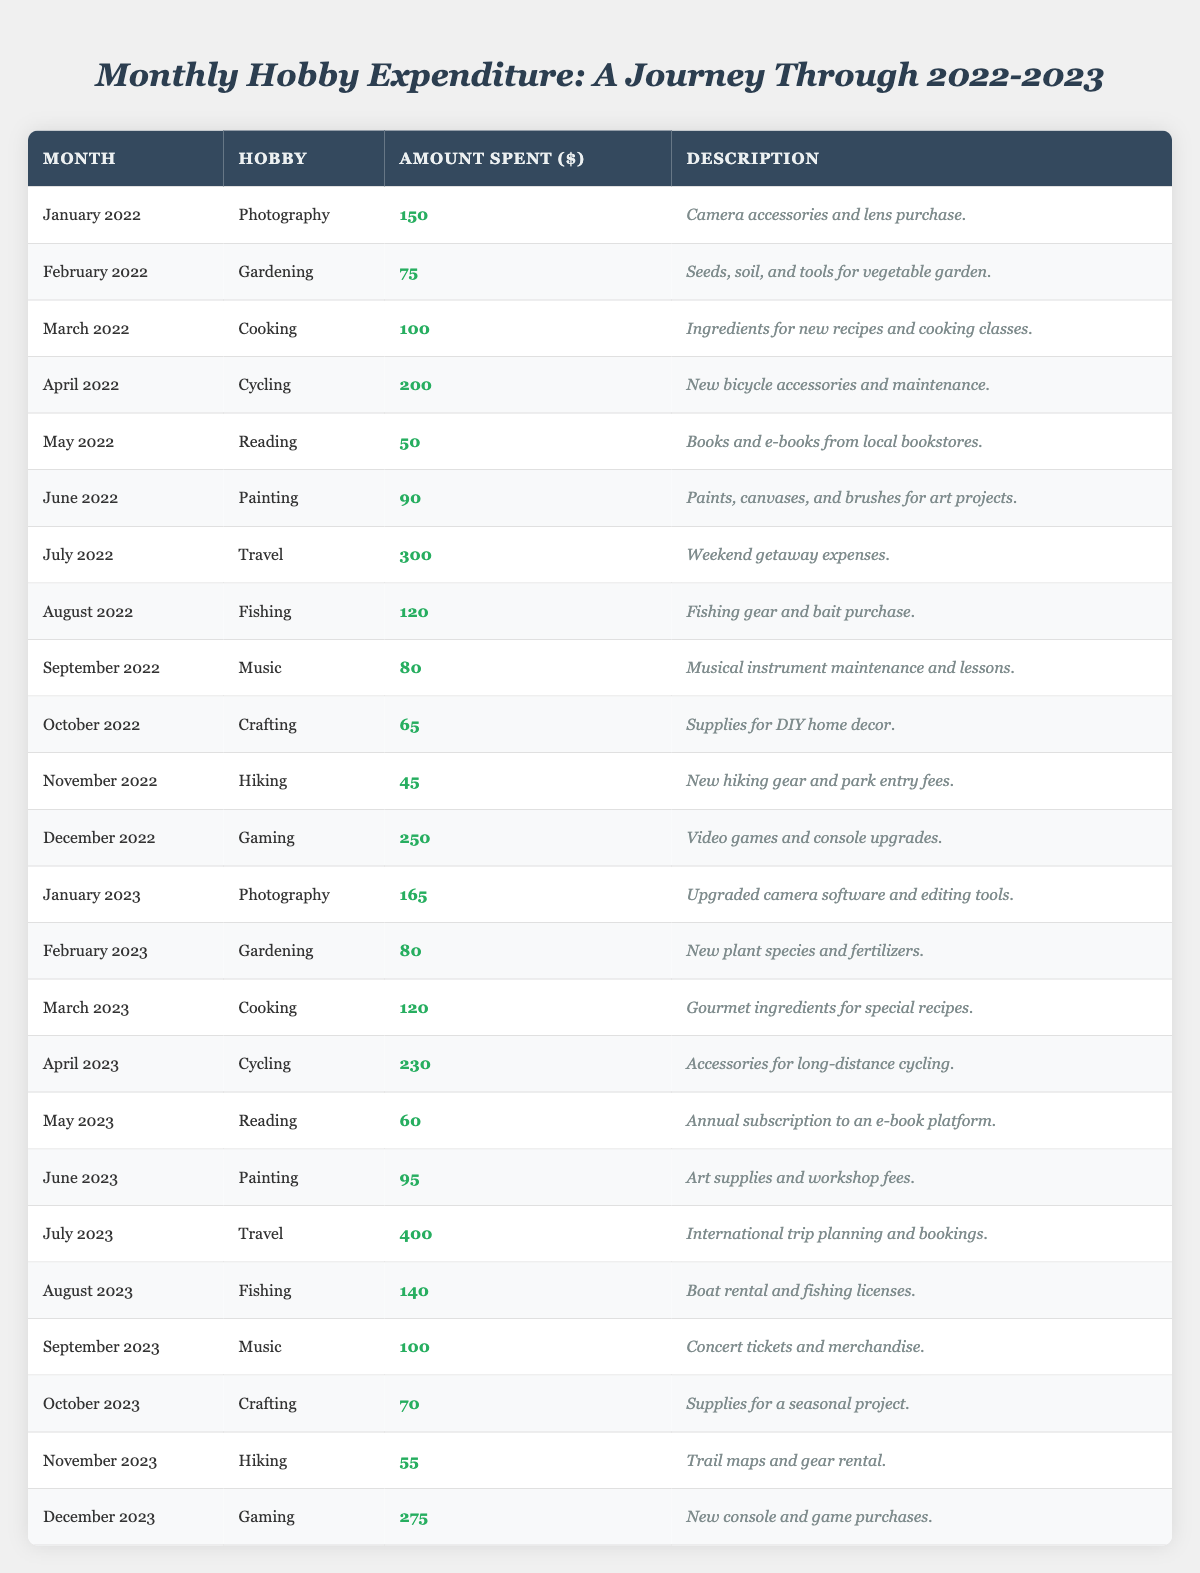What was the total expenditure on Cooking from 2022 to 2023? In 2022, the expenditure on Cooking was $100 in March and $120 in March 2023. Adding these amounts together gives $100 + $120 = $220.
Answer: $220 How much did Wilfredo spend on Gardening in February 2022 compared to February 2023? The expenditure on Gardening in February 2022 was $75, while in February 2023 it was $80. The difference is $80 - $75 = $5.
Answer: $5 Which hobby had the highest expenditure in July 2023? The only entry for July 2023 is Travel, which had an expenditure of $400.
Answer: Travel What is the average monthly expenditure on Fishing across all recorded months? The expenditures on Fishing were $120 in August 2022, $140 in August 2023. Summing these amounts gives $120 + $140 = $260, and there are 2 data points, so the average is $260/2 = $130.
Answer: $130 Did the expenditure on Gaming increase or decrease from December 2022 to December 2023? The expenditure on Gaming was $250 in December 2022 and increased to $275 in December 2023. Therefore, the statement is true: it increased.
Answer: Yes What was the highest single expenditure recorded and in which month? The highest single expenditure recorded was $400 in July 2023 for Travel.
Answer: $400 in July 2023 Calculate the total spent on Reading for both years combined. The expenditure on Reading was $50 in May 2022 and $60 in May 2023. Adding these amounts gives $50 + $60 = $110.
Answer: $110 Which month had the least expenditure on Hiking, and how much was spent? Looking at the expenditures for Hiking, the least amount was spent in November 2022 at $45.
Answer: November 2022, $45 Overall, did the total expenditures in 2023 exceed those in 2022? To find the total for 2022, sum all expenditures: $150 + $75 + $100 + $200 + $50 + $90 + $300 + $120 + $80 + $65 + $45 + $250 = $1,425. For 2023: $165 + $80 + $120 + $230 + $60 + $95 + $400 + $140 + $100 + $70 + $55 + $275 = $1,270. Since $1,270 < $1,425, it is false that 2023 expenditures exceeded 2022.
Answer: No What was the increase in expenditure for Photography from January 2022 to January 2023? The expenditure in January 2022 was $150, while in January 2023 it increased to $165. The increase is calculated as $165 - $150 = $15.
Answer: $15 